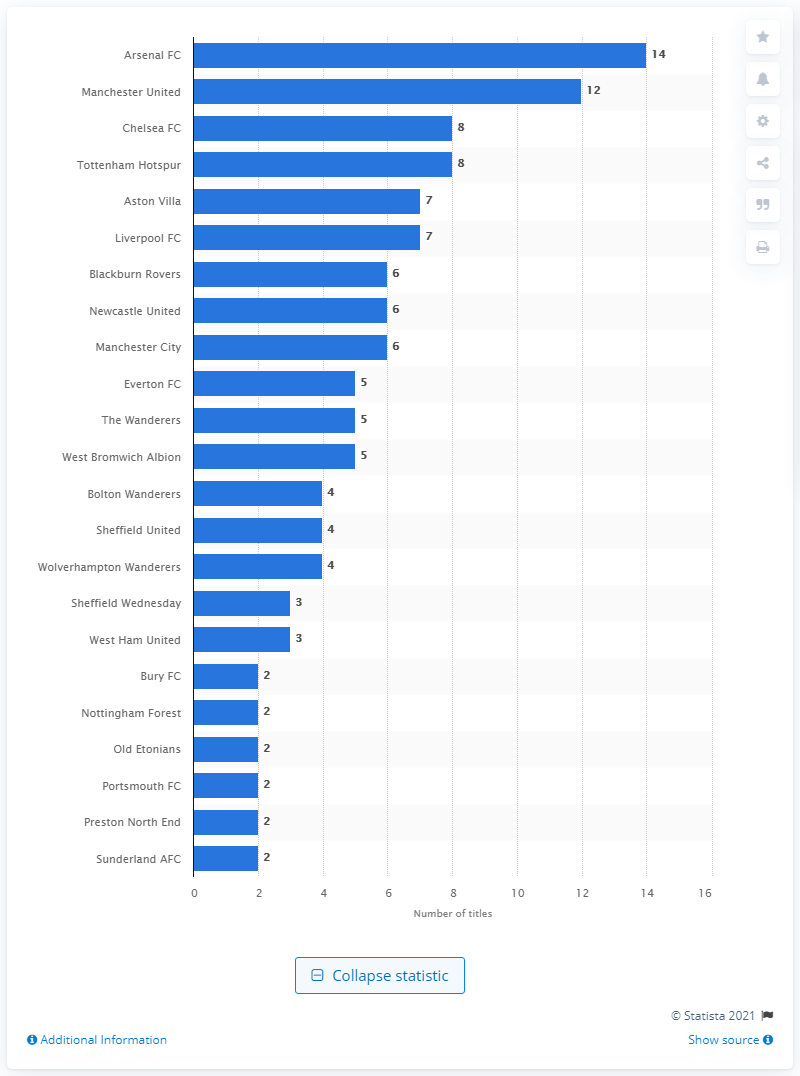List a handful of essential elements in this visual. Arsenal has won a total of 14 FA Cup titles, making it one of the most successful teams in the history of the prestigious competition. Manchester United has won the FA Cup 12 times, making it the team with the most victories in this prestigious football competition. 